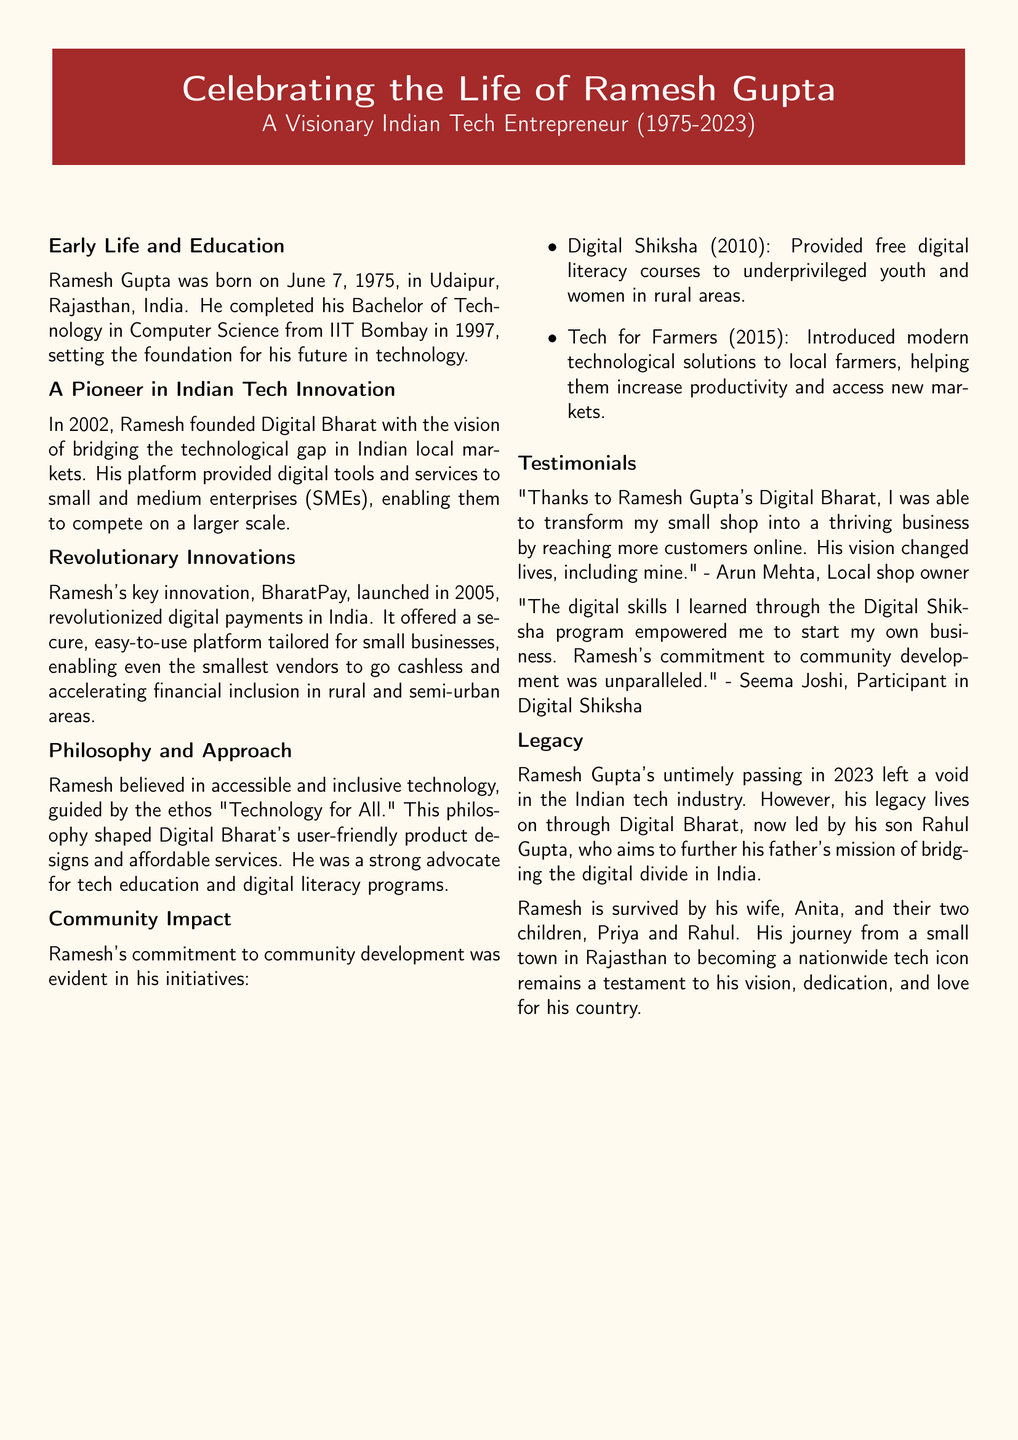What is Ramesh Gupta's date of birth? Ramesh Gupta was born on June 7, 1975, which is specified in the document.
Answer: June 7, 1975 What company did Ramesh Gupta found? The document states that Ramesh founded Digital Bharat in 2002.
Answer: Digital Bharat What was the key innovation launched by Ramesh in 2005? The document mentions BharatPay as the key innovation he launched in that year.
Answer: BharatPay What was Ramesh Gupta's educational qualification? The document outlines that he completed a Bachelor of Technology in Computer Science from IIT Bombay in 1997.
Answer: Bachelor of Technology in Computer Science In which year was the Digital Shiksha program initiated? The document specifies that Digital Shiksha was started in 2010.
Answer: 2010 What is the slogan that guided Ramesh Gupta's philosophy? The document highlights the ethos guiding Ramesh as "Technology for All."
Answer: Technology for All Who succeeded Ramesh Gupta at Digital Bharat? The document states that his son, Rahul Gupta, took over the leadership.
Answer: Rahul Gupta What was Ramesh Gupta's approach towards technology? The document indicates that Ramesh believed in accessible and inclusive technology.
Answer: Accessible and inclusive technology What is the primary impact of BharatPay mentioned in the document? The document explains that BharatPay allowed small vendors to go cashless and promoted financial inclusion.
Answer: Financial inclusion 